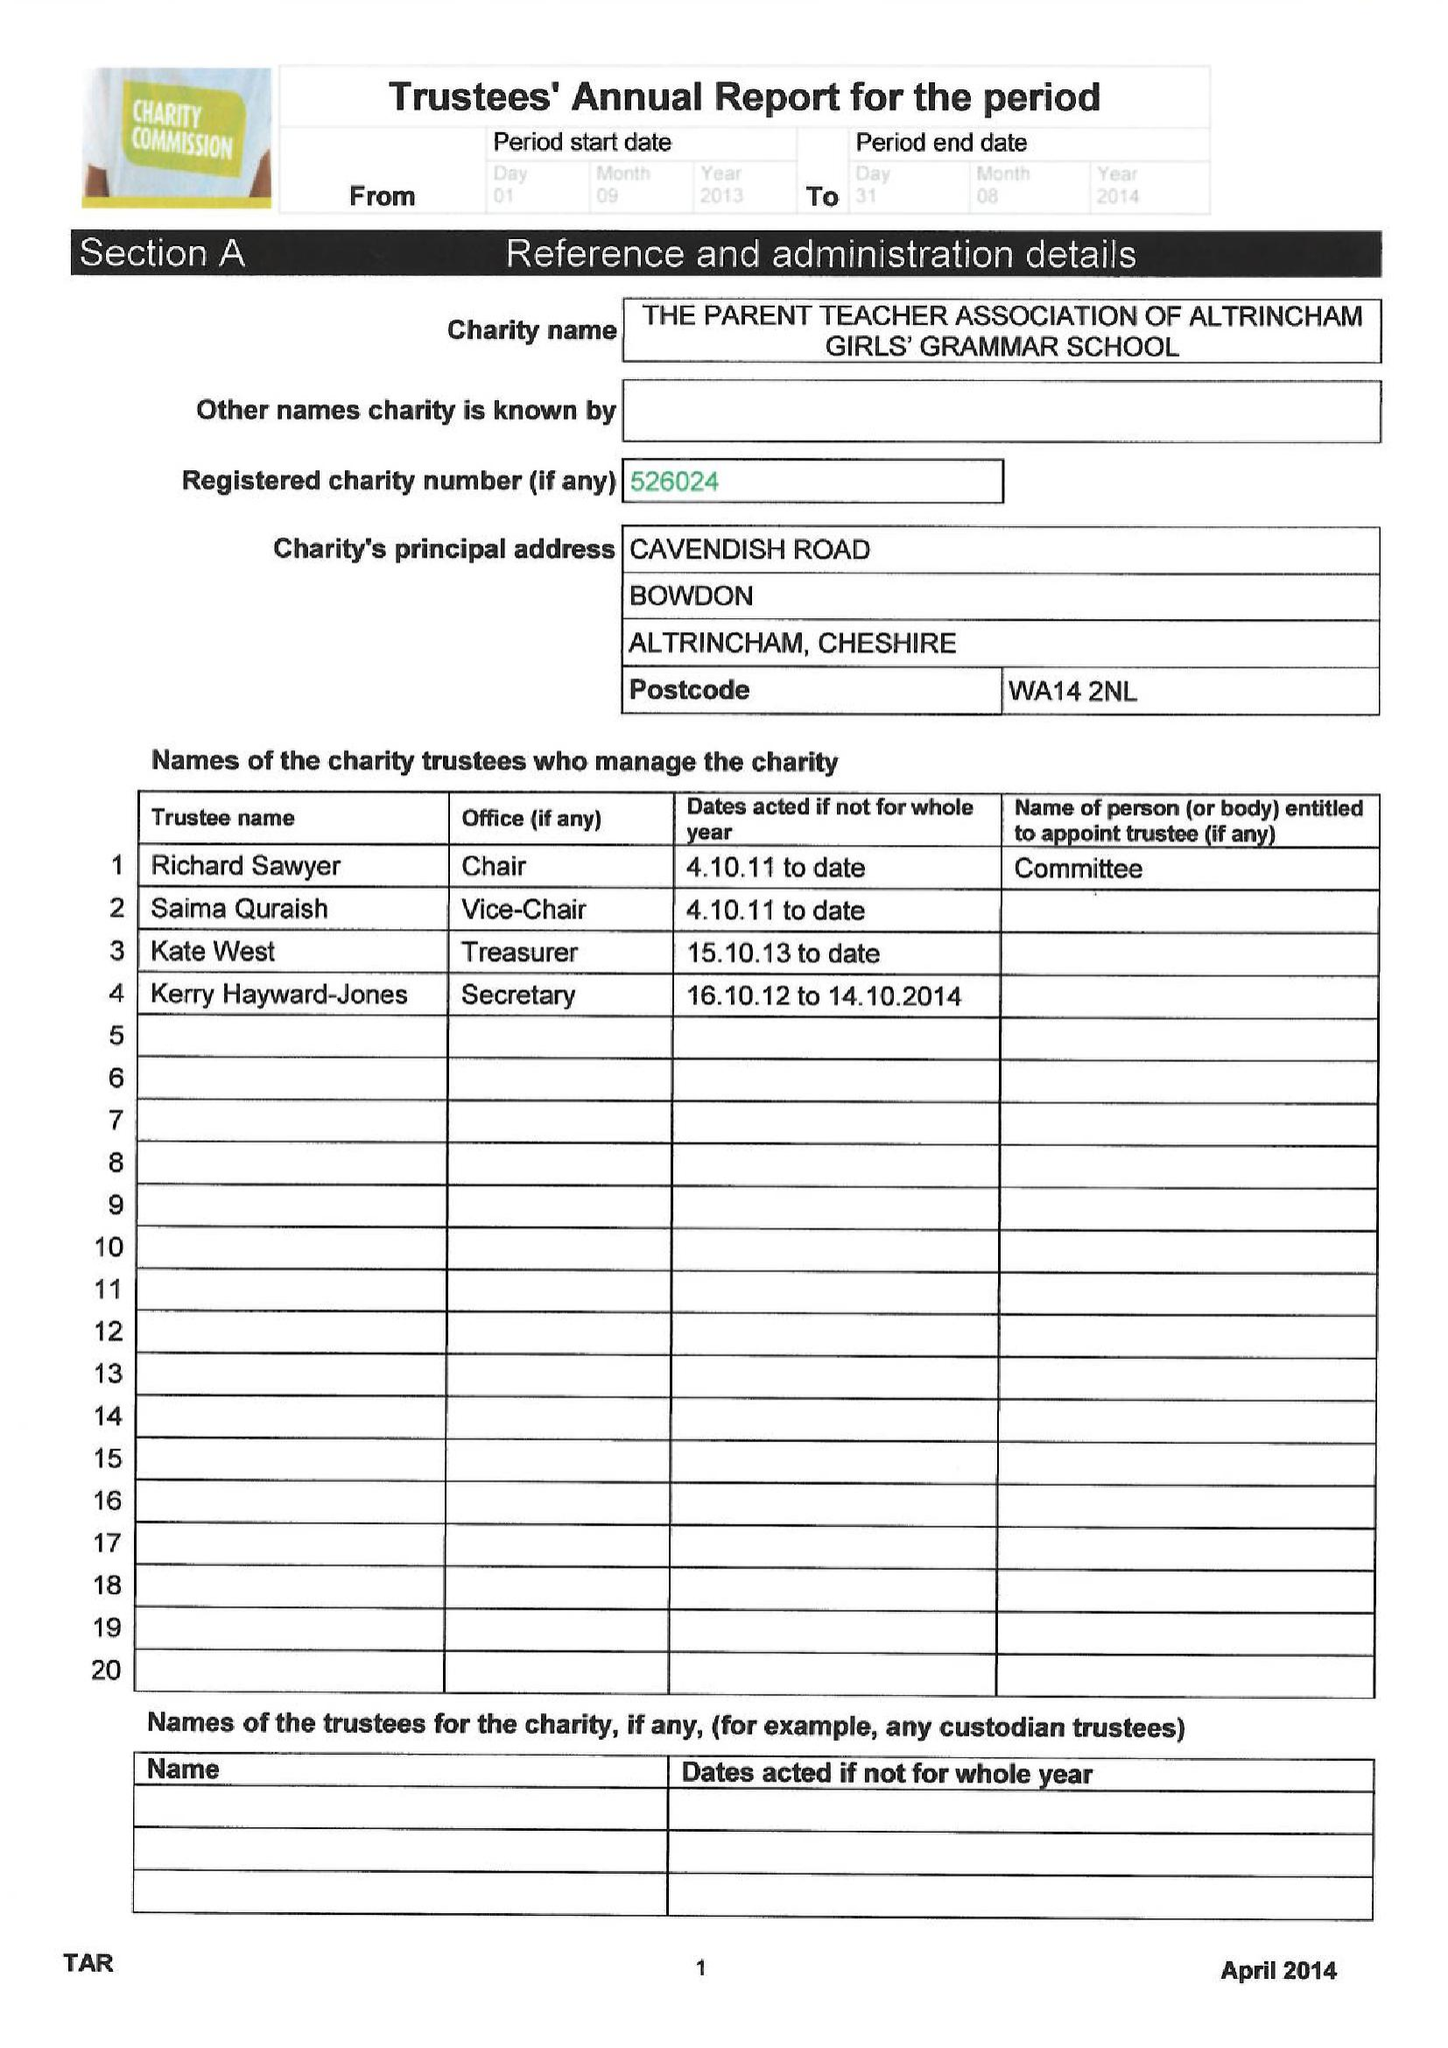What is the value for the address__postcode?
Answer the question using a single word or phrase. WA14 2NL 